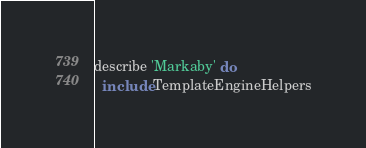<code> <loc_0><loc_0><loc_500><loc_500><_Ruby_>describe 'Markaby' do
  include TemplateEngineHelpers
</code> 